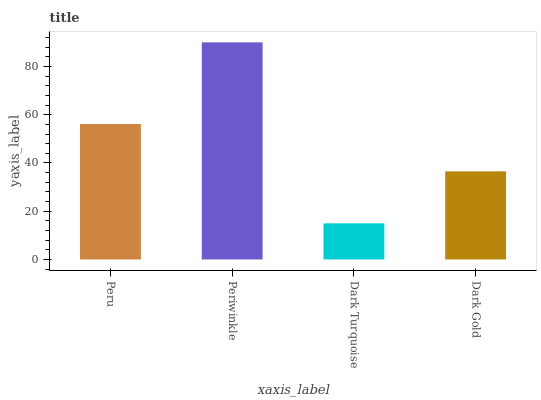Is Dark Turquoise the minimum?
Answer yes or no. Yes. Is Periwinkle the maximum?
Answer yes or no. Yes. Is Periwinkle the minimum?
Answer yes or no. No. Is Dark Turquoise the maximum?
Answer yes or no. No. Is Periwinkle greater than Dark Turquoise?
Answer yes or no. Yes. Is Dark Turquoise less than Periwinkle?
Answer yes or no. Yes. Is Dark Turquoise greater than Periwinkle?
Answer yes or no. No. Is Periwinkle less than Dark Turquoise?
Answer yes or no. No. Is Peru the high median?
Answer yes or no. Yes. Is Dark Gold the low median?
Answer yes or no. Yes. Is Dark Gold the high median?
Answer yes or no. No. Is Periwinkle the low median?
Answer yes or no. No. 